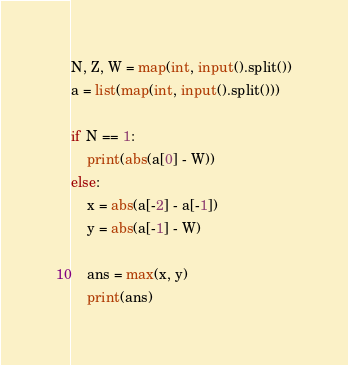<code> <loc_0><loc_0><loc_500><loc_500><_Python_>N, Z, W = map(int, input().split())
a = list(map(int, input().split()))

if N == 1:
    print(abs(a[0] - W))
else:
    x = abs(a[-2] - a[-1])
    y = abs(a[-1] - W)
    
    ans = max(x, y)
    print(ans)
</code> 